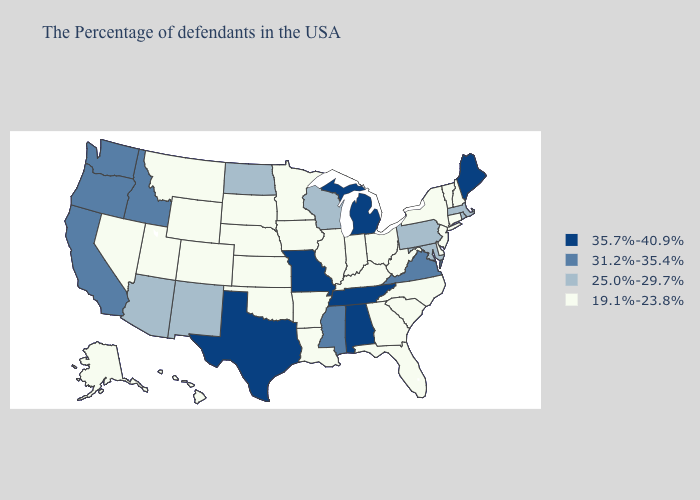Name the states that have a value in the range 19.1%-23.8%?
Be succinct. New Hampshire, Vermont, Connecticut, New York, New Jersey, Delaware, North Carolina, South Carolina, West Virginia, Ohio, Florida, Georgia, Kentucky, Indiana, Illinois, Louisiana, Arkansas, Minnesota, Iowa, Kansas, Nebraska, Oklahoma, South Dakota, Wyoming, Colorado, Utah, Montana, Nevada, Alaska, Hawaii. What is the highest value in states that border Connecticut?
Short answer required. 25.0%-29.7%. Name the states that have a value in the range 31.2%-35.4%?
Quick response, please. Virginia, Mississippi, Idaho, California, Washington, Oregon. Does Idaho have the highest value in the West?
Quick response, please. Yes. What is the value of South Carolina?
Concise answer only. 19.1%-23.8%. Name the states that have a value in the range 35.7%-40.9%?
Give a very brief answer. Maine, Michigan, Alabama, Tennessee, Missouri, Texas. Does Wisconsin have the lowest value in the USA?
Answer briefly. No. What is the lowest value in states that border Oregon?
Quick response, please. 19.1%-23.8%. Does Alaska have the lowest value in the West?
Keep it brief. Yes. Name the states that have a value in the range 35.7%-40.9%?
Quick response, please. Maine, Michigan, Alabama, Tennessee, Missouri, Texas. What is the value of Pennsylvania?
Write a very short answer. 25.0%-29.7%. Name the states that have a value in the range 31.2%-35.4%?
Write a very short answer. Virginia, Mississippi, Idaho, California, Washington, Oregon. Does the first symbol in the legend represent the smallest category?
Answer briefly. No. Does New Jersey have the lowest value in the Northeast?
Concise answer only. Yes. What is the value of Arkansas?
Give a very brief answer. 19.1%-23.8%. 